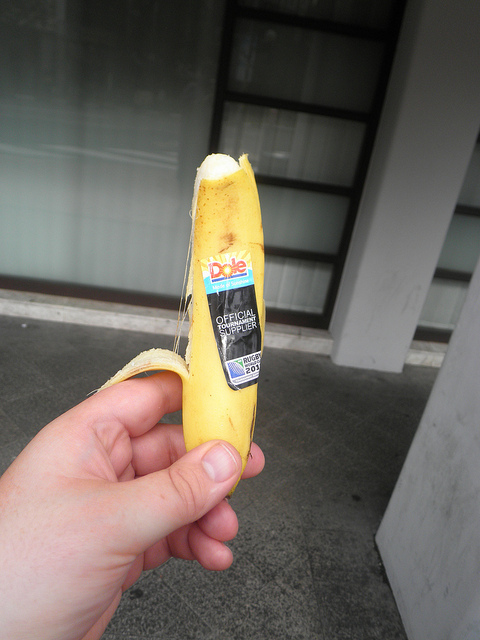Please transcribe the text information in this image. DOLE OFFICIAL OFFICIAL TOURNAMENT SUPPLIER TOURNAMENT RUG8 